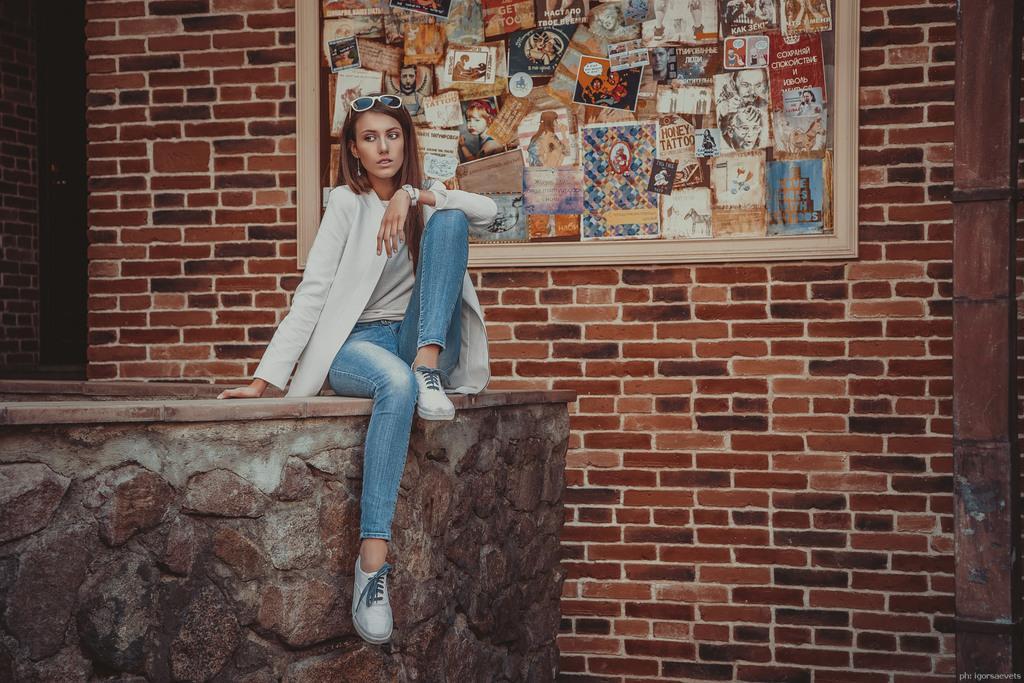Please provide a concise description of this image. In this image there is a girl sitting on the rock is staring at something, behind the girl there is a brick wall with a photo frame on the wall. 